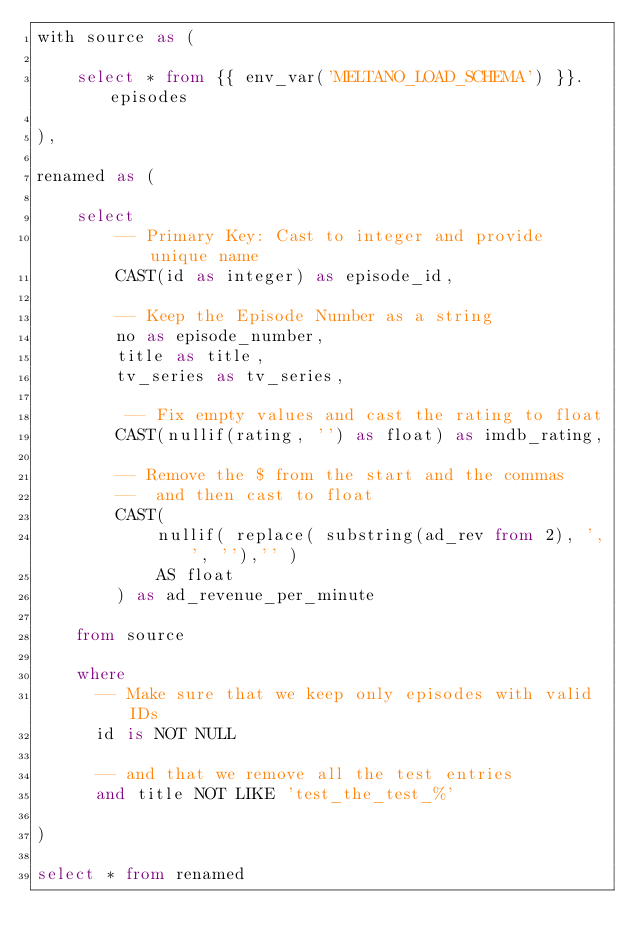Convert code to text. <code><loc_0><loc_0><loc_500><loc_500><_SQL_>with source as (

    select * from {{ env_var('MELTANO_LOAD_SCHEMA') }}.episodes

),

renamed as (

    select
        -- Primary Key: Cast to integer and provide unique name
        CAST(id as integer) as episode_id,

        -- Keep the Episode Number as a string
        no as episode_number,
        title as title,
        tv_series as tv_series,

         -- Fix empty values and cast the rating to float
        CAST(nullif(rating, '') as float) as imdb_rating,

        -- Remove the $ from the start and the commas
        --  and then cast to float
        CAST(
            nullif( replace( substring(ad_rev from 2), ',', ''),'' )
            AS float
        ) as ad_revenue_per_minute

    from source

    where
      -- Make sure that we keep only episodes with valid IDs
      id is NOT NULL

      -- and that we remove all the test entries
      and title NOT LIKE 'test_the_test_%'

)

select * from renamed
</code> 